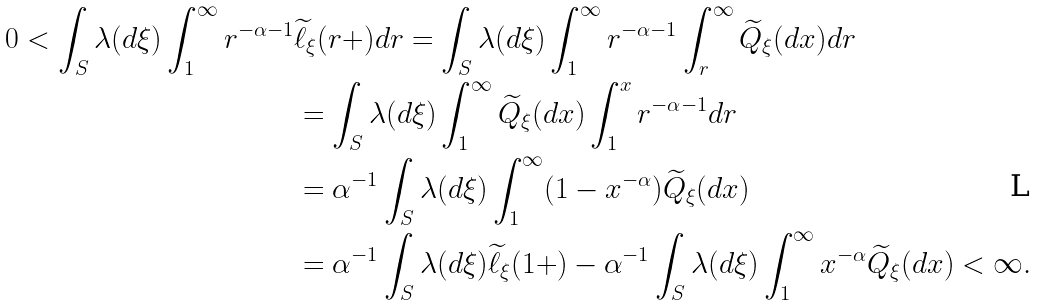<formula> <loc_0><loc_0><loc_500><loc_500>0 < \int _ { S } \lambda ( d \xi ) \int _ { 1 } ^ { \infty } r ^ { - \alpha - 1 } & \widetilde { \ell } _ { \xi } ( r + ) d r = \int _ { S } \lambda ( d \xi ) \int _ { 1 } ^ { \infty } r ^ { - \alpha - 1 } \int _ { r } ^ { \infty } \widetilde { Q } _ { \xi } ( d x ) d r \\ & = \int _ { S } \lambda ( d \xi ) \int _ { 1 } ^ { \infty } \widetilde { Q } _ { \xi } ( d x ) \int _ { 1 } ^ { x } r ^ { - \alpha - 1 } d r \\ & = { \alpha } ^ { - 1 } \int _ { S } \lambda ( d \xi ) \int _ { 1 } ^ { \infty } ( { 1 - x ^ { - \alpha } } ) \widetilde { Q } _ { \xi } ( d x ) \\ & = { \alpha } ^ { - 1 } \int _ { S } \lambda ( d \xi ) { \widetilde { \ell } _ { \xi } ( 1 + ) } - { \alpha } ^ { - 1 } \int _ { S } \lambda ( d \xi ) \int _ { 1 } ^ { \infty } x ^ { - \alpha } \widetilde { Q } _ { \xi } ( d x ) < \infty .</formula> 